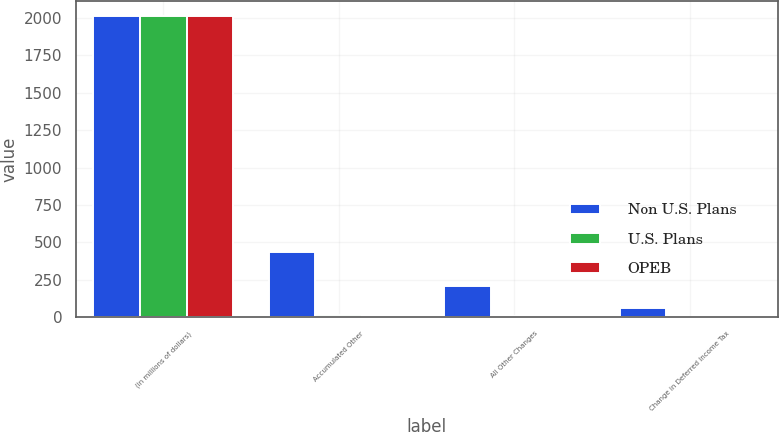Convert chart. <chart><loc_0><loc_0><loc_500><loc_500><stacked_bar_chart><ecel><fcel>(in millions of dollars)<fcel>Accumulated Other<fcel>All Other Changes<fcel>Change in Deferred Income Tax<nl><fcel>Non U.S. Plans<fcel>2011<fcel>437.6<fcel>207.5<fcel>61.7<nl><fcel>U.S. Plans<fcel>2011<fcel>17.2<fcel>8.7<fcel>2.2<nl><fcel>OPEB<fcel>2011<fcel>10.7<fcel>5.5<fcel>3.5<nl></chart> 